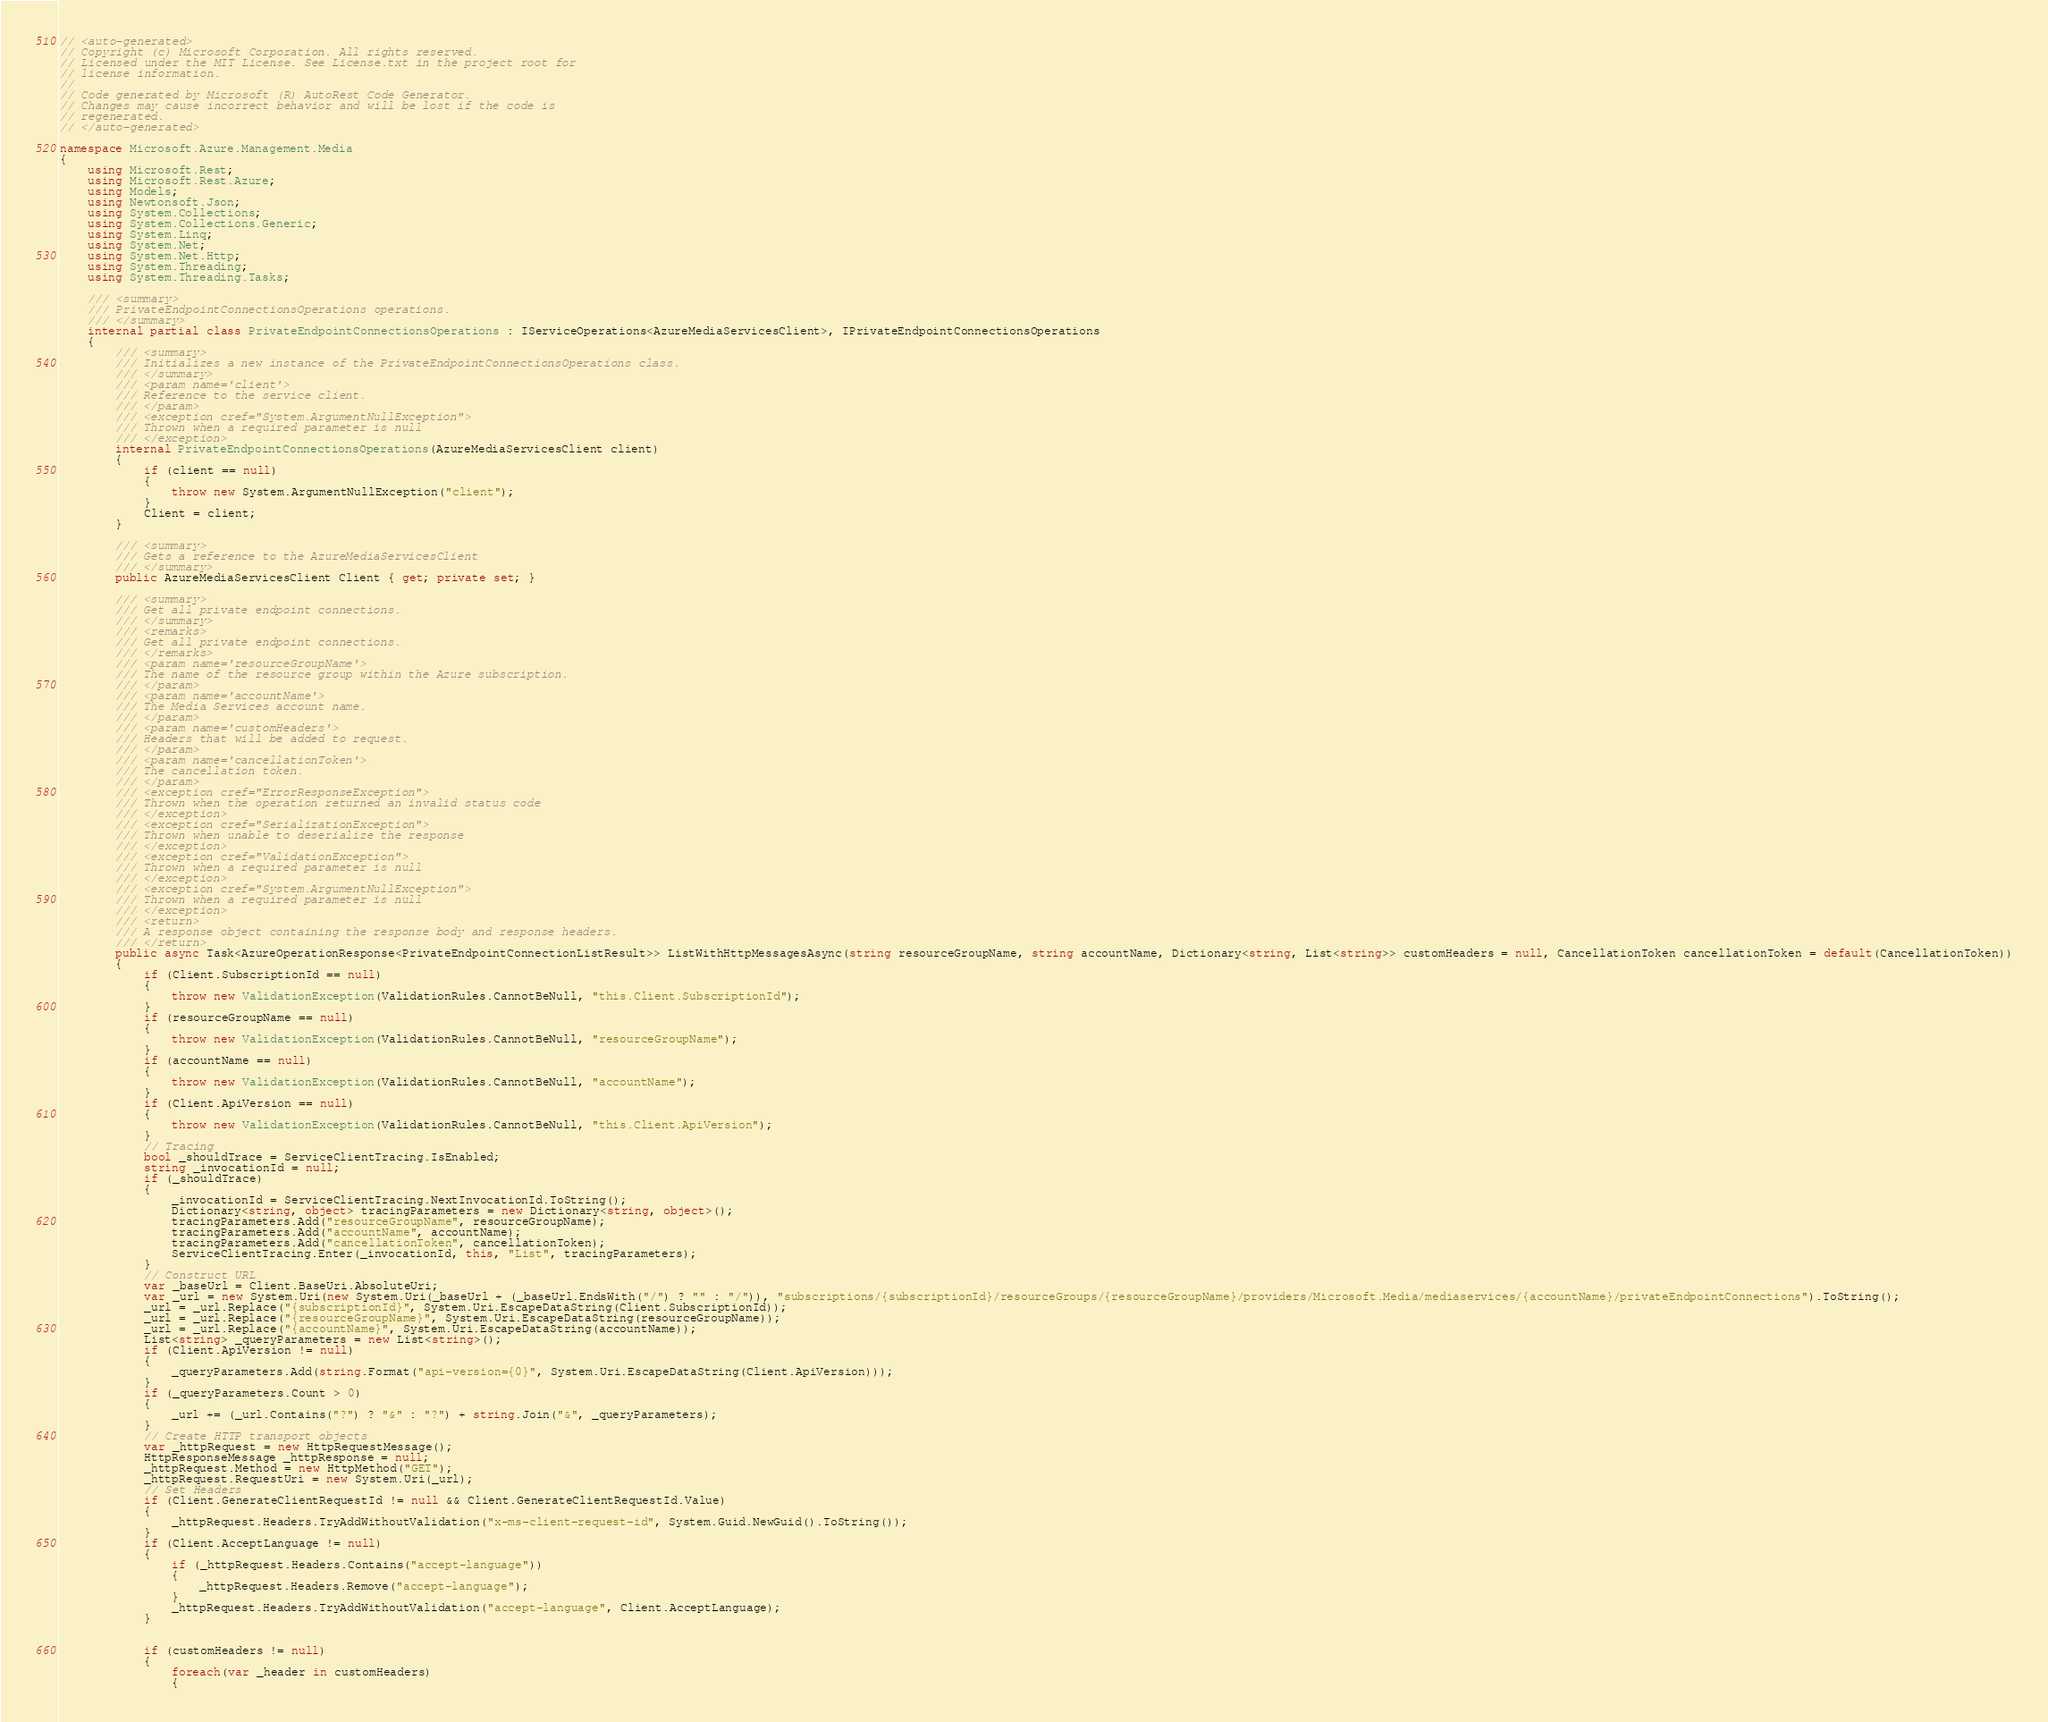Convert code to text. <code><loc_0><loc_0><loc_500><loc_500><_C#_>// <auto-generated>
// Copyright (c) Microsoft Corporation. All rights reserved.
// Licensed under the MIT License. See License.txt in the project root for
// license information.
//
// Code generated by Microsoft (R) AutoRest Code Generator.
// Changes may cause incorrect behavior and will be lost if the code is
// regenerated.
// </auto-generated>

namespace Microsoft.Azure.Management.Media
{
    using Microsoft.Rest;
    using Microsoft.Rest.Azure;
    using Models;
    using Newtonsoft.Json;
    using System.Collections;
    using System.Collections.Generic;
    using System.Linq;
    using System.Net;
    using System.Net.Http;
    using System.Threading;
    using System.Threading.Tasks;

    /// <summary>
    /// PrivateEndpointConnectionsOperations operations.
    /// </summary>
    internal partial class PrivateEndpointConnectionsOperations : IServiceOperations<AzureMediaServicesClient>, IPrivateEndpointConnectionsOperations
    {
        /// <summary>
        /// Initializes a new instance of the PrivateEndpointConnectionsOperations class.
        /// </summary>
        /// <param name='client'>
        /// Reference to the service client.
        /// </param>
        /// <exception cref="System.ArgumentNullException">
        /// Thrown when a required parameter is null
        /// </exception>
        internal PrivateEndpointConnectionsOperations(AzureMediaServicesClient client)
        {
            if (client == null)
            {
                throw new System.ArgumentNullException("client");
            }
            Client = client;
        }

        /// <summary>
        /// Gets a reference to the AzureMediaServicesClient
        /// </summary>
        public AzureMediaServicesClient Client { get; private set; }

        /// <summary>
        /// Get all private endpoint connections.
        /// </summary>
        /// <remarks>
        /// Get all private endpoint connections.
        /// </remarks>
        /// <param name='resourceGroupName'>
        /// The name of the resource group within the Azure subscription.
        /// </param>
        /// <param name='accountName'>
        /// The Media Services account name.
        /// </param>
        /// <param name='customHeaders'>
        /// Headers that will be added to request.
        /// </param>
        /// <param name='cancellationToken'>
        /// The cancellation token.
        /// </param>
        /// <exception cref="ErrorResponseException">
        /// Thrown when the operation returned an invalid status code
        /// </exception>
        /// <exception cref="SerializationException">
        /// Thrown when unable to deserialize the response
        /// </exception>
        /// <exception cref="ValidationException">
        /// Thrown when a required parameter is null
        /// </exception>
        /// <exception cref="System.ArgumentNullException">
        /// Thrown when a required parameter is null
        /// </exception>
        /// <return>
        /// A response object containing the response body and response headers.
        /// </return>
        public async Task<AzureOperationResponse<PrivateEndpointConnectionListResult>> ListWithHttpMessagesAsync(string resourceGroupName, string accountName, Dictionary<string, List<string>> customHeaders = null, CancellationToken cancellationToken = default(CancellationToken))
        {
            if (Client.SubscriptionId == null)
            {
                throw new ValidationException(ValidationRules.CannotBeNull, "this.Client.SubscriptionId");
            }
            if (resourceGroupName == null)
            {
                throw new ValidationException(ValidationRules.CannotBeNull, "resourceGroupName");
            }
            if (accountName == null)
            {
                throw new ValidationException(ValidationRules.CannotBeNull, "accountName");
            }
            if (Client.ApiVersion == null)
            {
                throw new ValidationException(ValidationRules.CannotBeNull, "this.Client.ApiVersion");
            }
            // Tracing
            bool _shouldTrace = ServiceClientTracing.IsEnabled;
            string _invocationId = null;
            if (_shouldTrace)
            {
                _invocationId = ServiceClientTracing.NextInvocationId.ToString();
                Dictionary<string, object> tracingParameters = new Dictionary<string, object>();
                tracingParameters.Add("resourceGroupName", resourceGroupName);
                tracingParameters.Add("accountName", accountName);
                tracingParameters.Add("cancellationToken", cancellationToken);
                ServiceClientTracing.Enter(_invocationId, this, "List", tracingParameters);
            }
            // Construct URL
            var _baseUrl = Client.BaseUri.AbsoluteUri;
            var _url = new System.Uri(new System.Uri(_baseUrl + (_baseUrl.EndsWith("/") ? "" : "/")), "subscriptions/{subscriptionId}/resourceGroups/{resourceGroupName}/providers/Microsoft.Media/mediaservices/{accountName}/privateEndpointConnections").ToString();
            _url = _url.Replace("{subscriptionId}", System.Uri.EscapeDataString(Client.SubscriptionId));
            _url = _url.Replace("{resourceGroupName}", System.Uri.EscapeDataString(resourceGroupName));
            _url = _url.Replace("{accountName}", System.Uri.EscapeDataString(accountName));
            List<string> _queryParameters = new List<string>();
            if (Client.ApiVersion != null)
            {
                _queryParameters.Add(string.Format("api-version={0}", System.Uri.EscapeDataString(Client.ApiVersion)));
            }
            if (_queryParameters.Count > 0)
            {
                _url += (_url.Contains("?") ? "&" : "?") + string.Join("&", _queryParameters);
            }
            // Create HTTP transport objects
            var _httpRequest = new HttpRequestMessage();
            HttpResponseMessage _httpResponse = null;
            _httpRequest.Method = new HttpMethod("GET");
            _httpRequest.RequestUri = new System.Uri(_url);
            // Set Headers
            if (Client.GenerateClientRequestId != null && Client.GenerateClientRequestId.Value)
            {
                _httpRequest.Headers.TryAddWithoutValidation("x-ms-client-request-id", System.Guid.NewGuid().ToString());
            }
            if (Client.AcceptLanguage != null)
            {
                if (_httpRequest.Headers.Contains("accept-language"))
                {
                    _httpRequest.Headers.Remove("accept-language");
                }
                _httpRequest.Headers.TryAddWithoutValidation("accept-language", Client.AcceptLanguage);
            }


            if (customHeaders != null)
            {
                foreach(var _header in customHeaders)
                {</code> 